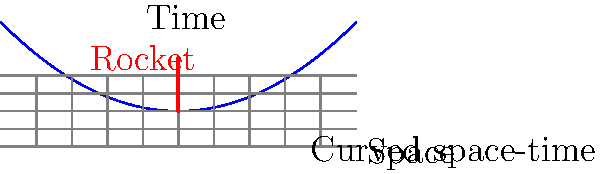As a local historian documenting space exploration at the Plesetsk Cosmodrome, you're studying the effects of massive objects on space-time. Given that the curvature of space-time near a rocket launch site can be approximated by the equation $y = 0.1x^2$, where $y$ represents the time axis and $x$ represents the space axis, what is the proper time $\tau$ experienced by an observer at the launch site $(x=0)$ compared to the coordinate time $t$ experienced by a distant observer, assuming the rocket's presence causes significant local curvature? To solve this problem, we need to follow these steps:

1) In general relativity, the proper time $\tau$ experienced by an observer in a curved space-time is related to the coordinate time $t$ by the metric of the space-time.

2) For a static observer in a curved space-time described by $y = 0.1x^2$, we can use the metric:

   $$ds^2 = -(1+2\Phi)dt^2 + (1-2\Phi)(dx^2+dy^2+dz^2)$$

   where $\Phi$ is the gravitational potential.

3) In our case, $\Phi$ can be approximated by the curvature function:

   $$\Phi \approx 0.1x^2$$

4) For an observer at the launch site $(x=0)$, the metric simplifies to:

   $$ds^2 = -dt^2$$

   because $\Phi(0) = 0$.

5) The proper time $\tau$ is defined by $ds^2 = -d\tau^2$, so for our observer:

   $$d\tau^2 = dt^2$$

6) This means that for the observer at the launch site:

   $$\tau = t$$

Therefore, the proper time experienced by an observer at the launch site is equal to the coordinate time experienced by a distant observer.
Answer: $\tau = t$ 